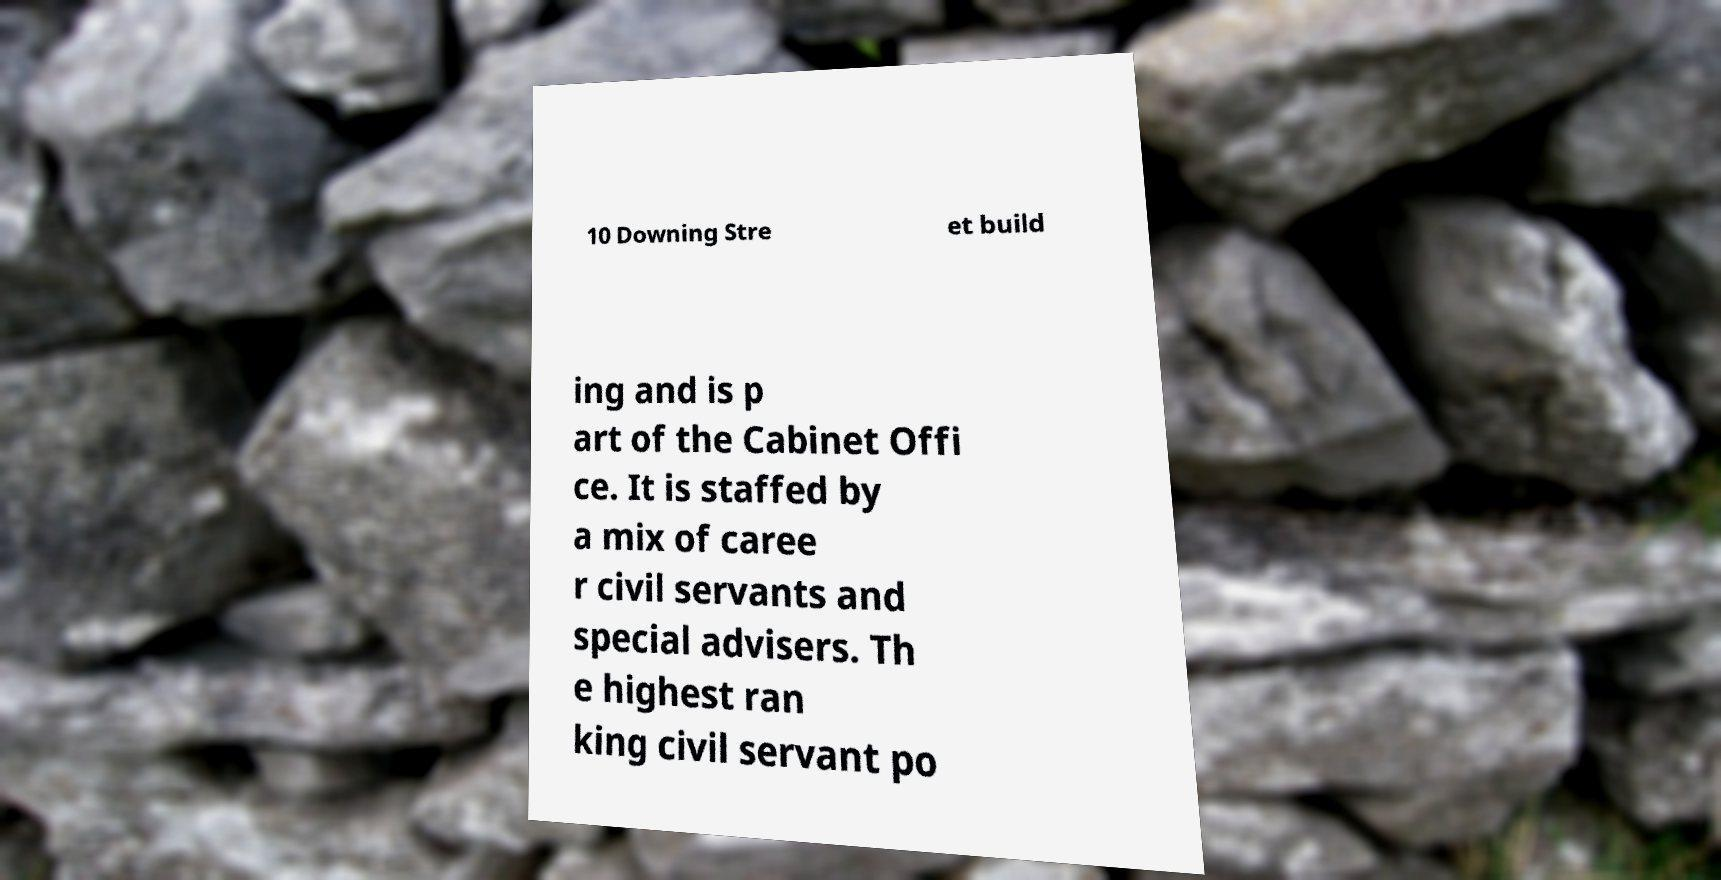Could you assist in decoding the text presented in this image and type it out clearly? 10 Downing Stre et build ing and is p art of the Cabinet Offi ce. It is staffed by a mix of caree r civil servants and special advisers. Th e highest ran king civil servant po 